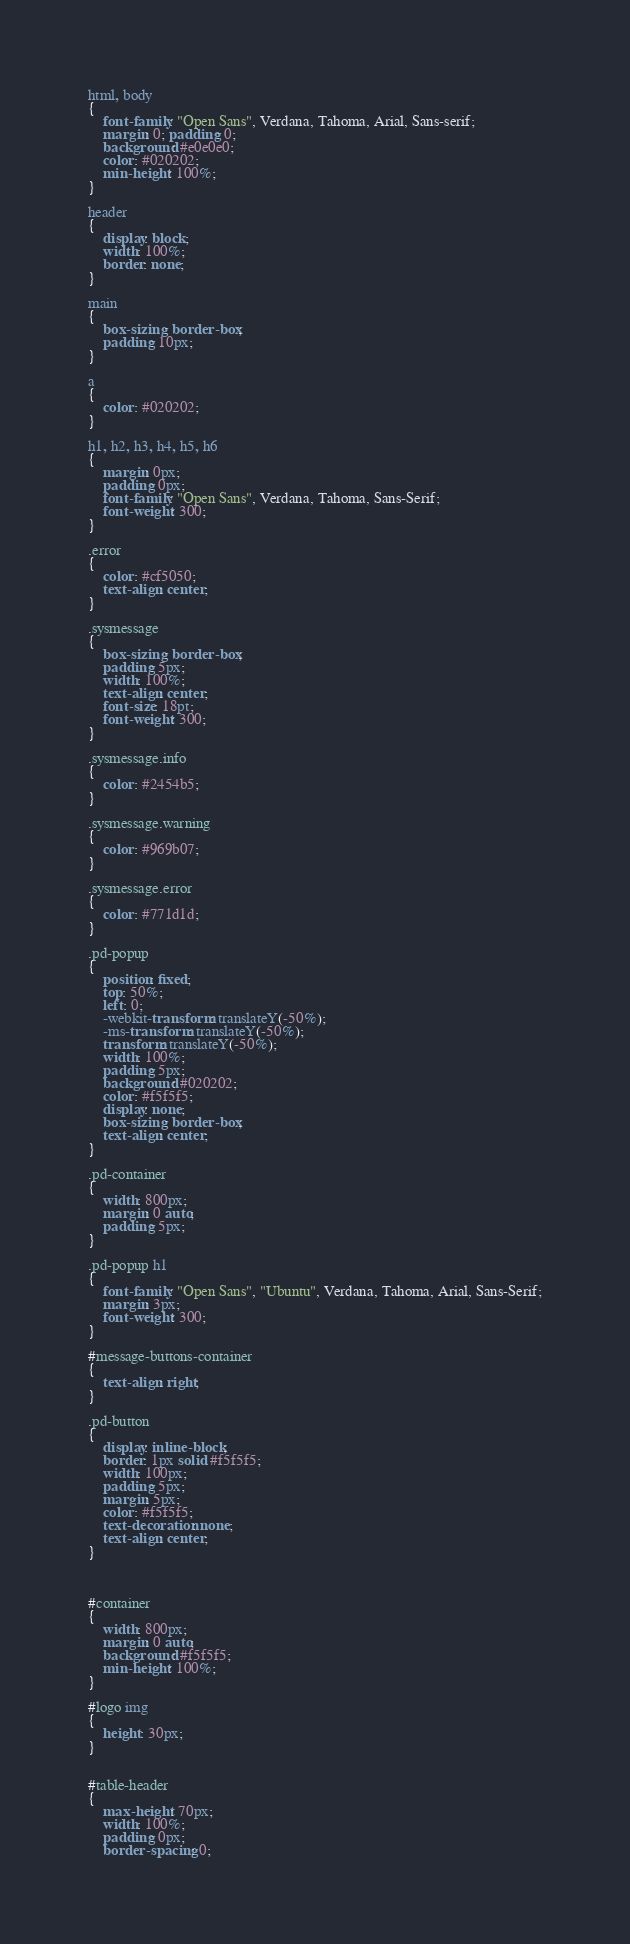<code> <loc_0><loc_0><loc_500><loc_500><_CSS_>html, body
{
	font-family: "Open Sans", Verdana, Tahoma, Arial, Sans-serif;
	margin: 0; padding: 0;
	background: #e0e0e0;
	color: #020202;
	min-height: 100%;
}

header
{
	display: block;
	width: 100%;
	border: none;
}

main
{
	box-sizing: border-box;
	padding: 10px;
}

a
{
	color: #020202;
}

h1, h2, h3, h4, h5, h6
{
	margin: 0px;
	padding: 0px;
	font-family: "Open Sans", Verdana, Tahoma, Sans-Serif;
	font-weight: 300;
}

.error
{
	color: #cf5050;
	text-align: center;
}

.sysmessage
{
	box-sizing: border-box;
	padding: 5px;
	width: 100%;
	text-align: center;
	font-size: 18pt;
	font-weight: 300;
}

.sysmessage.info
{
	color: #2454b5;
}

.sysmessage.warning
{
	color: #969b07;
}

.sysmessage.error
{
	color: #771d1d;
}

.pd-popup
{
	position: fixed;
	top: 50%;
	left: 0;
	-webkit-transform: translateY(-50%);
	-ms-transform: translateY(-50%);
	transform: translateY(-50%);
	width: 100%;
	padding: 5px;
	background: #020202;
	color: #f5f5f5;
	display: none;
	box-sizing: border-box;
	text-align: center;
}

.pd-container
{
	width: 800px;
	margin: 0 auto;
	padding: 5px;
}

.pd-popup h1
{
	font-family: "Open Sans", "Ubuntu", Verdana, Tahoma, Arial, Sans-Serif;
	margin: 3px;
	font-weight: 300;
}

#message-buttons-container
{
	text-align: right;
}

.pd-button
{
	display: inline-block;
	border: 1px solid #f5f5f5;
	width: 100px;
	padding: 5px;
	margin: 5px;
	color: #f5f5f5;
	text-decoration: none;
	text-align: center;
}



#container
{
	width: 800px;
	margin: 0 auto;
	background: #f5f5f5;
	min-height: 100%;
}

#logo img
{
	height: 30px;
}


#table-header
{
	max-height: 70px;
	width: 100%;
	padding: 0px;
	border-spacing: 0;
</code> 